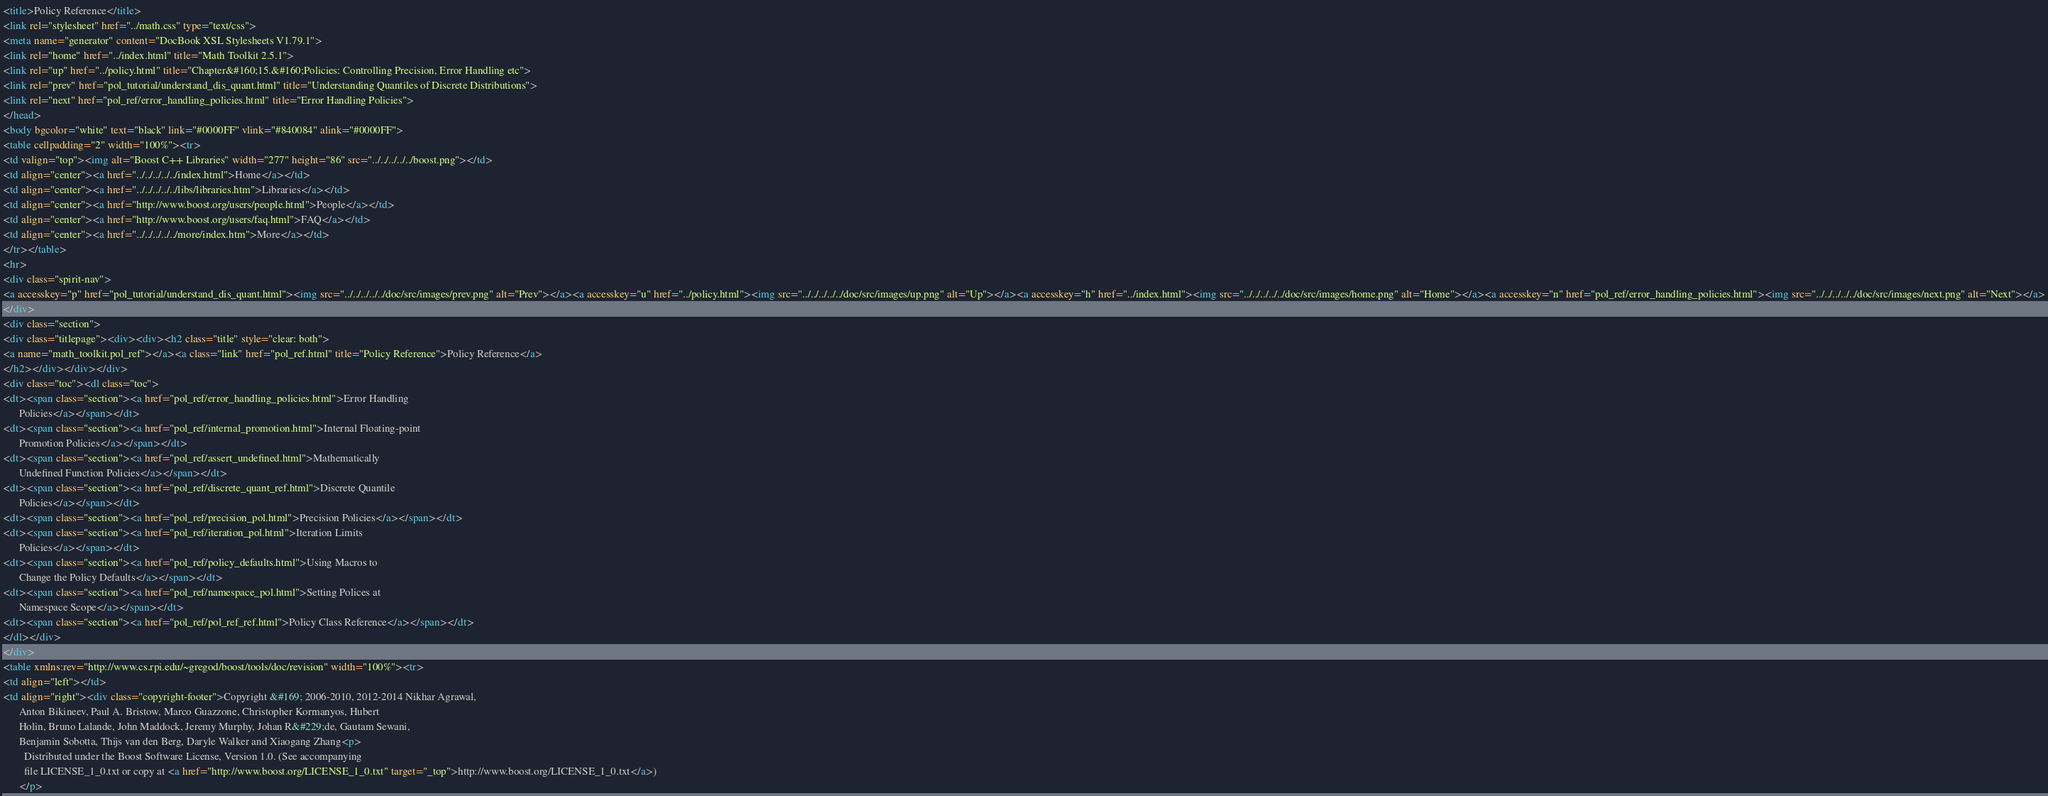<code> <loc_0><loc_0><loc_500><loc_500><_HTML_><title>Policy Reference</title>
<link rel="stylesheet" href="../math.css" type="text/css">
<meta name="generator" content="DocBook XSL Stylesheets V1.79.1">
<link rel="home" href="../index.html" title="Math Toolkit 2.5.1">
<link rel="up" href="../policy.html" title="Chapter&#160;15.&#160;Policies: Controlling Precision, Error Handling etc">
<link rel="prev" href="pol_tutorial/understand_dis_quant.html" title="Understanding Quantiles of Discrete Distributions">
<link rel="next" href="pol_ref/error_handling_policies.html" title="Error Handling Policies">
</head>
<body bgcolor="white" text="black" link="#0000FF" vlink="#840084" alink="#0000FF">
<table cellpadding="2" width="100%"><tr>
<td valign="top"><img alt="Boost C++ Libraries" width="277" height="86" src="../../../../../boost.png"></td>
<td align="center"><a href="../../../../../index.html">Home</a></td>
<td align="center"><a href="../../../../../libs/libraries.htm">Libraries</a></td>
<td align="center"><a href="http://www.boost.org/users/people.html">People</a></td>
<td align="center"><a href="http://www.boost.org/users/faq.html">FAQ</a></td>
<td align="center"><a href="../../../../../more/index.htm">More</a></td>
</tr></table>
<hr>
<div class="spirit-nav">
<a accesskey="p" href="pol_tutorial/understand_dis_quant.html"><img src="../../../../../doc/src/images/prev.png" alt="Prev"></a><a accesskey="u" href="../policy.html"><img src="../../../../../doc/src/images/up.png" alt="Up"></a><a accesskey="h" href="../index.html"><img src="../../../../../doc/src/images/home.png" alt="Home"></a><a accesskey="n" href="pol_ref/error_handling_policies.html"><img src="../../../../../doc/src/images/next.png" alt="Next"></a>
</div>
<div class="section">
<div class="titlepage"><div><div><h2 class="title" style="clear: both">
<a name="math_toolkit.pol_ref"></a><a class="link" href="pol_ref.html" title="Policy Reference">Policy Reference</a>
</h2></div></div></div>
<div class="toc"><dl class="toc">
<dt><span class="section"><a href="pol_ref/error_handling_policies.html">Error Handling
      Policies</a></span></dt>
<dt><span class="section"><a href="pol_ref/internal_promotion.html">Internal Floating-point
      Promotion Policies</a></span></dt>
<dt><span class="section"><a href="pol_ref/assert_undefined.html">Mathematically
      Undefined Function Policies</a></span></dt>
<dt><span class="section"><a href="pol_ref/discrete_quant_ref.html">Discrete Quantile
      Policies</a></span></dt>
<dt><span class="section"><a href="pol_ref/precision_pol.html">Precision Policies</a></span></dt>
<dt><span class="section"><a href="pol_ref/iteration_pol.html">Iteration Limits
      Policies</a></span></dt>
<dt><span class="section"><a href="pol_ref/policy_defaults.html">Using Macros to
      Change the Policy Defaults</a></span></dt>
<dt><span class="section"><a href="pol_ref/namespace_pol.html">Setting Polices at
      Namespace Scope</a></span></dt>
<dt><span class="section"><a href="pol_ref/pol_ref_ref.html">Policy Class Reference</a></span></dt>
</dl></div>
</div>
<table xmlns:rev="http://www.cs.rpi.edu/~gregod/boost/tools/doc/revision" width="100%"><tr>
<td align="left"></td>
<td align="right"><div class="copyright-footer">Copyright &#169; 2006-2010, 2012-2014 Nikhar Agrawal,
      Anton Bikineev, Paul A. Bristow, Marco Guazzone, Christopher Kormanyos, Hubert
      Holin, Bruno Lalande, John Maddock, Jeremy Murphy, Johan R&#229;de, Gautam Sewani,
      Benjamin Sobotta, Thijs van den Berg, Daryle Walker and Xiaogang Zhang<p>
        Distributed under the Boost Software License, Version 1.0. (See accompanying
        file LICENSE_1_0.txt or copy at <a href="http://www.boost.org/LICENSE_1_0.txt" target="_top">http://www.boost.org/LICENSE_1_0.txt</a>)
      </p></code> 